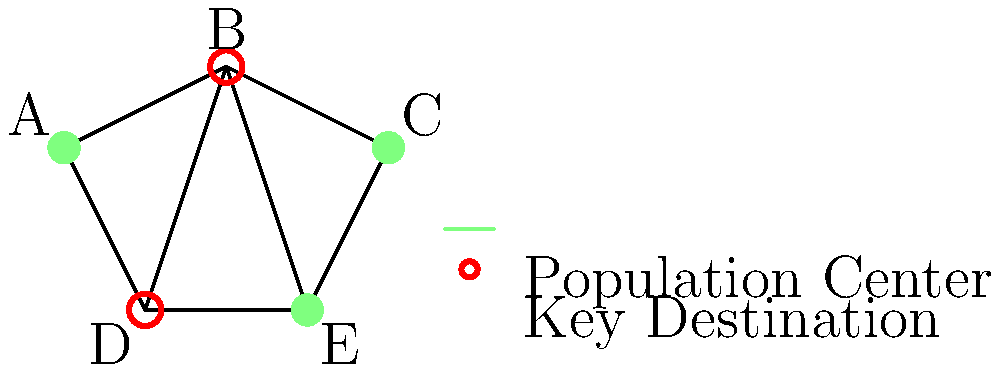Given the city map above, where A, C, and E are major population centers, and B and D are key destinations, design an efficient public transportation route system that connects all points. What is the minimum number of routes needed to ensure all population centers are connected to all key destinations with at most one transfer? To solve this problem, we need to follow these steps:

1. Identify the requirements:
   - All population centers (A, C, E) must be connected to all key destinations (B, D).
   - Passengers should reach any key destination from any population center with at most one transfer.

2. Analyze the map:
   - A is directly connected to B and D.
   - C is directly connected to B and E.
   - E is directly connected to C and D.

3. Design the routes:
   - Route 1: A - B - C
     This connects two population centers (A and C) to one key destination (B).
   - Route 2: A - D - E
     This connects two population centers (A and E) to one key destination (D).

4. Verify the connections:
   - A is directly connected to both B and D.
   - C is directly connected to B and can reach D with one transfer at A or E.
   - E is directly connected to D and can reach B with one transfer at C or A.

5. Check for alternatives:
   - We cannot reduce the number of routes further without violating the "at most one transfer" requirement.
   - Adding more routes would be redundant and less efficient.

Therefore, the minimum number of routes needed is 2.
Answer: 2 routes 